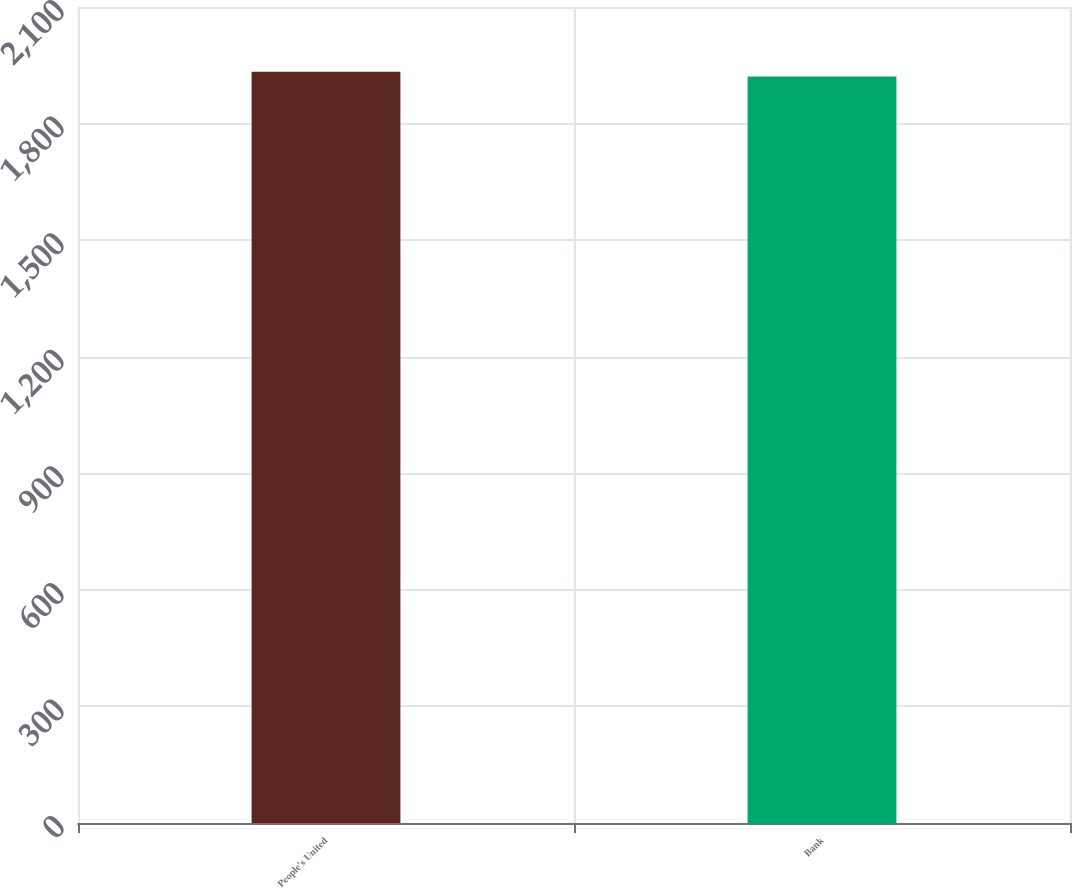<chart> <loc_0><loc_0><loc_500><loc_500><bar_chart><fcel>People's United<fcel>Bank<nl><fcel>1933.4<fcel>1921.2<nl></chart> 